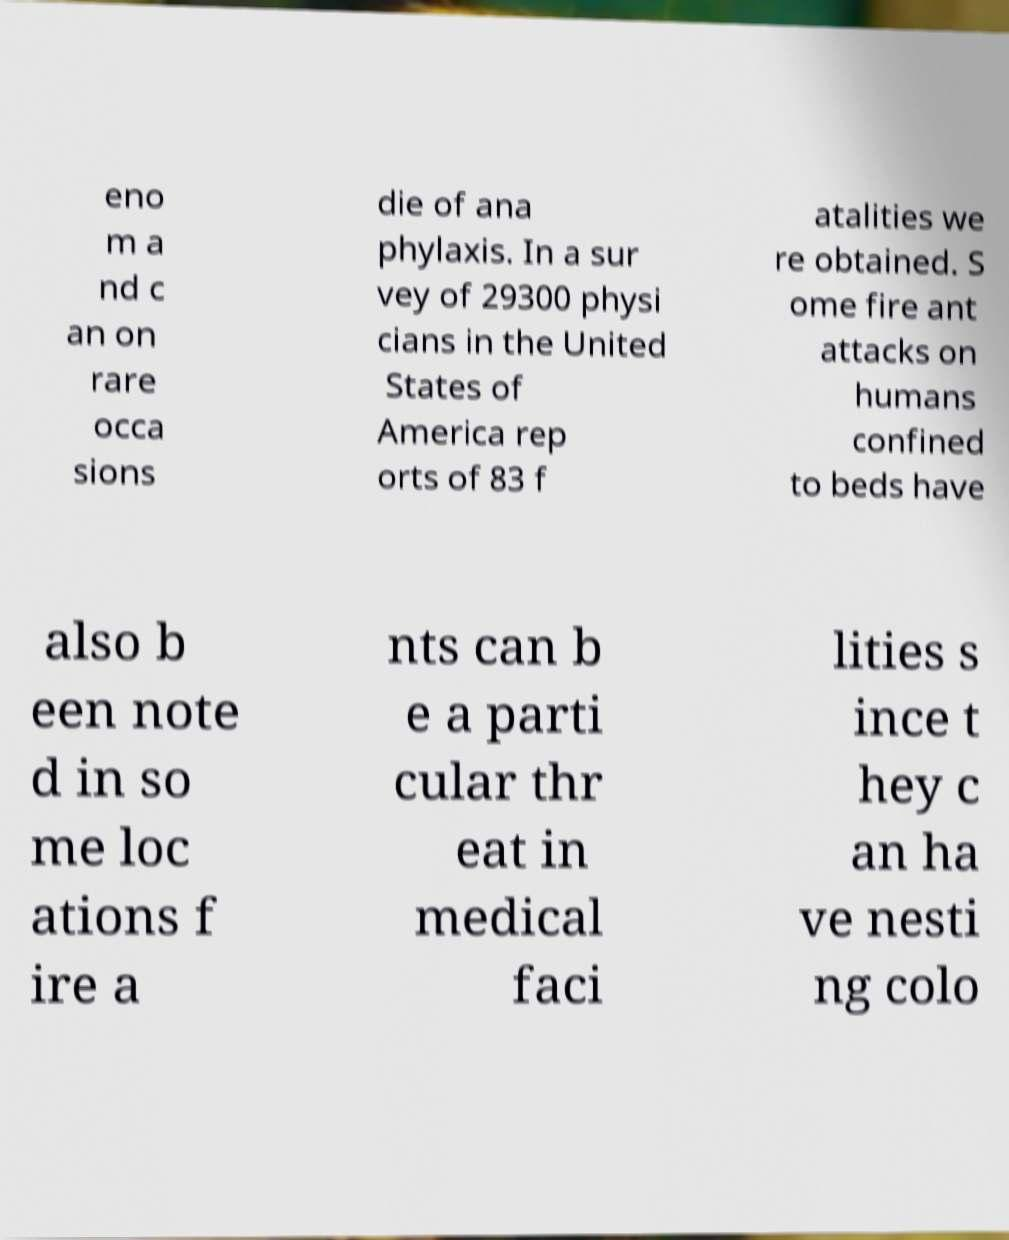What messages or text are displayed in this image? I need them in a readable, typed format. eno m a nd c an on rare occa sions die of ana phylaxis. In a sur vey of 29300 physi cians in the United States of America rep orts of 83 f atalities we re obtained. S ome fire ant attacks on humans confined to beds have also b een note d in so me loc ations f ire a nts can b e a parti cular thr eat in medical faci lities s ince t hey c an ha ve nesti ng colo 